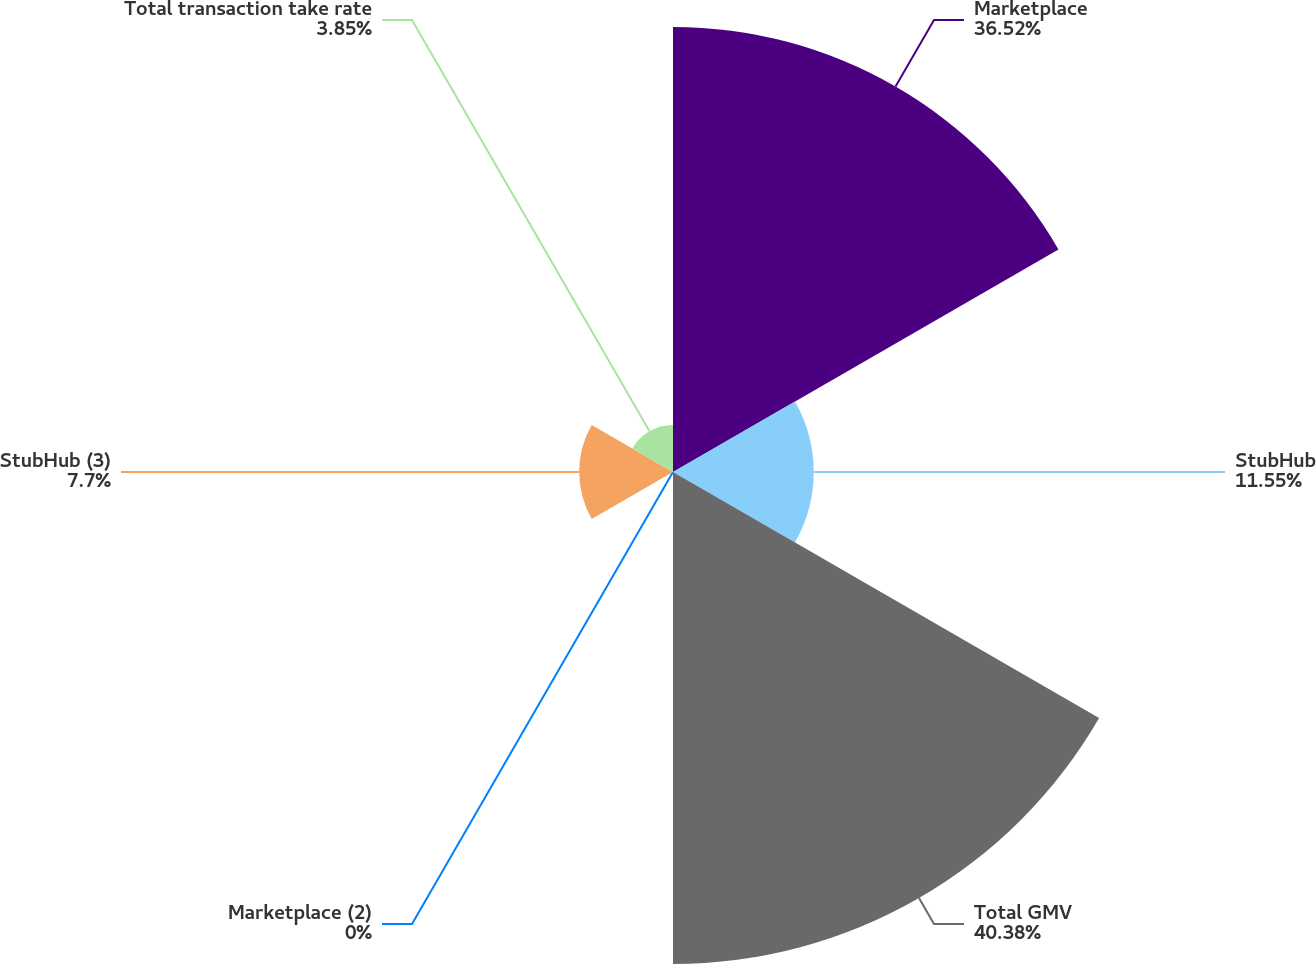<chart> <loc_0><loc_0><loc_500><loc_500><pie_chart><fcel>Marketplace<fcel>StubHub<fcel>Total GMV<fcel>Marketplace (2)<fcel>StubHub (3)<fcel>Total transaction take rate<nl><fcel>36.52%<fcel>11.55%<fcel>40.37%<fcel>0.0%<fcel>7.7%<fcel>3.85%<nl></chart> 